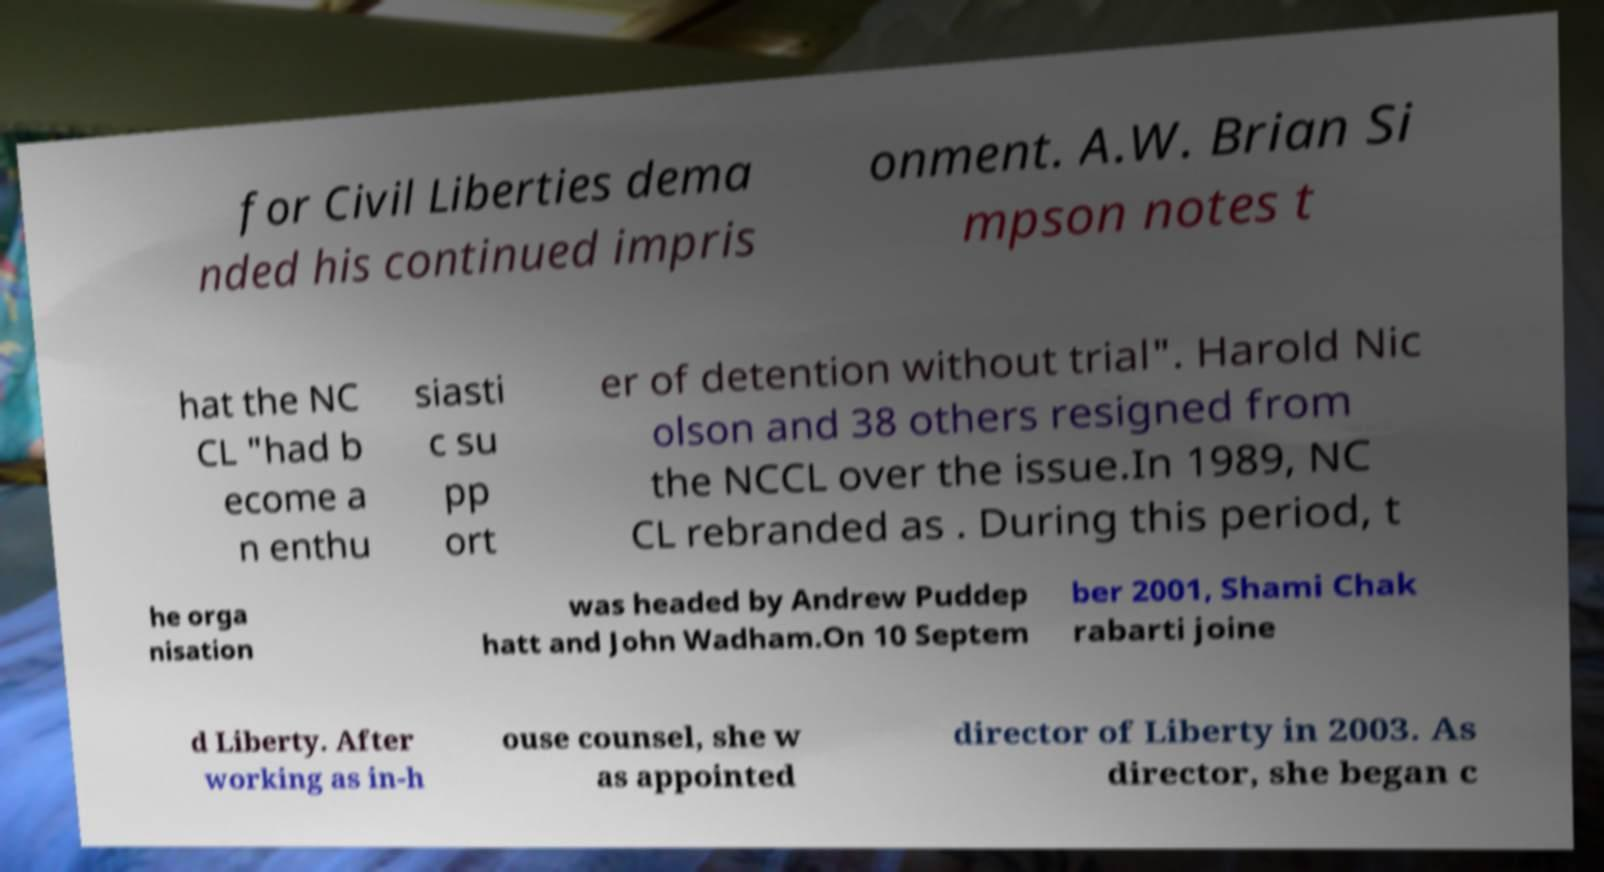Could you assist in decoding the text presented in this image and type it out clearly? for Civil Liberties dema nded his continued impris onment. A.W. Brian Si mpson notes t hat the NC CL "had b ecome a n enthu siasti c su pp ort er of detention without trial". Harold Nic olson and 38 others resigned from the NCCL over the issue.In 1989, NC CL rebranded as . During this period, t he orga nisation was headed by Andrew Puddep hatt and John Wadham.On 10 Septem ber 2001, Shami Chak rabarti joine d Liberty. After working as in-h ouse counsel, she w as appointed director of Liberty in 2003. As director, she began c 